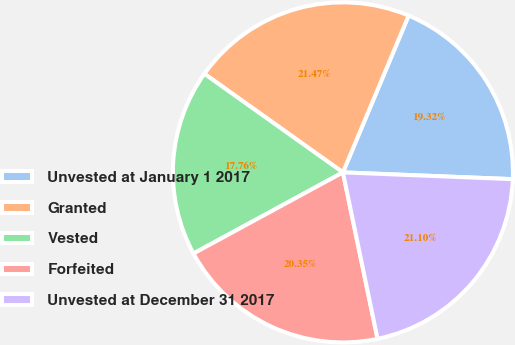Convert chart. <chart><loc_0><loc_0><loc_500><loc_500><pie_chart><fcel>Unvested at January 1 2017<fcel>Granted<fcel>Vested<fcel>Forfeited<fcel>Unvested at December 31 2017<nl><fcel>19.32%<fcel>21.47%<fcel>17.76%<fcel>20.35%<fcel>21.1%<nl></chart> 